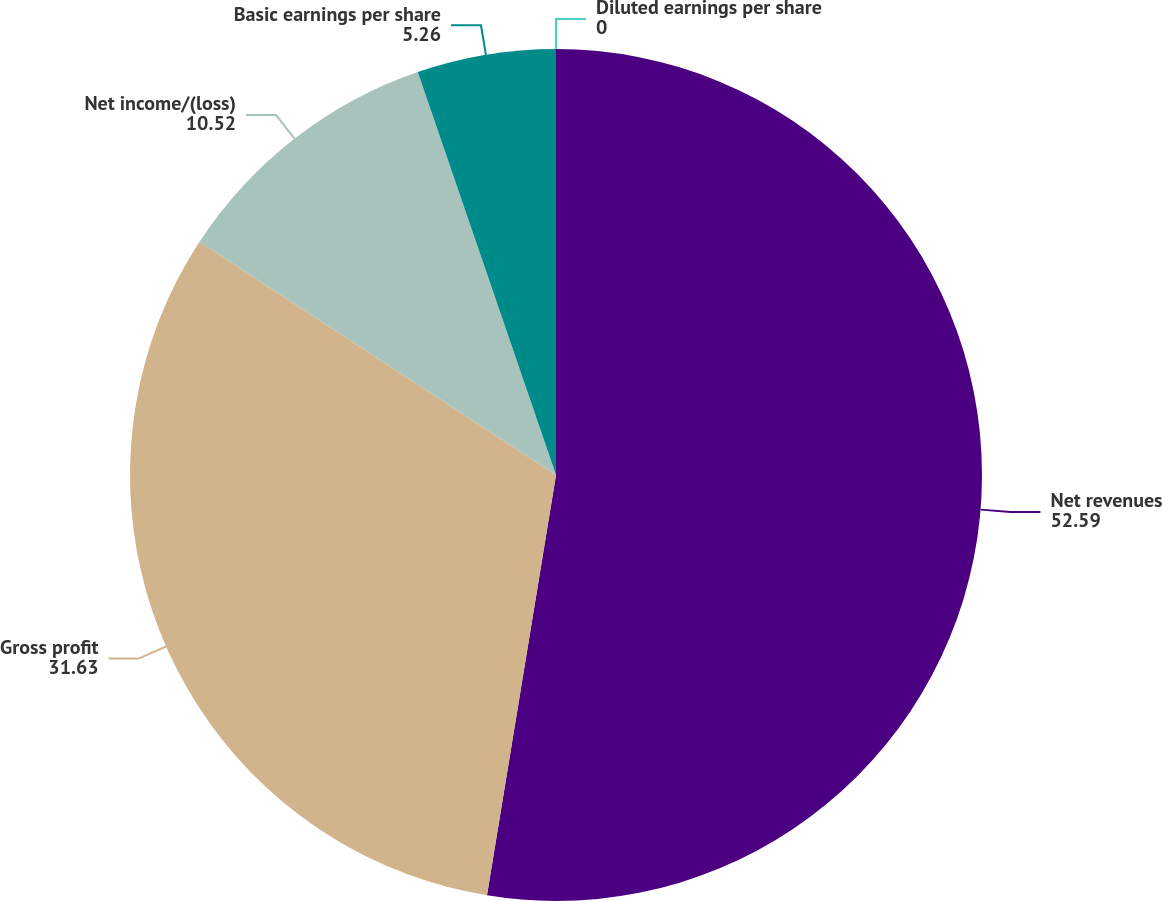Convert chart. <chart><loc_0><loc_0><loc_500><loc_500><pie_chart><fcel>Net revenues<fcel>Gross profit<fcel>Net income/(loss)<fcel>Basic earnings per share<fcel>Diluted earnings per share<nl><fcel>52.59%<fcel>31.63%<fcel>10.52%<fcel>5.26%<fcel>0.0%<nl></chart> 